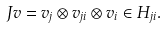Convert formula to latex. <formula><loc_0><loc_0><loc_500><loc_500>J v = v _ { j } \otimes v _ { j i } \otimes v _ { i } \in H _ { j i } .</formula> 